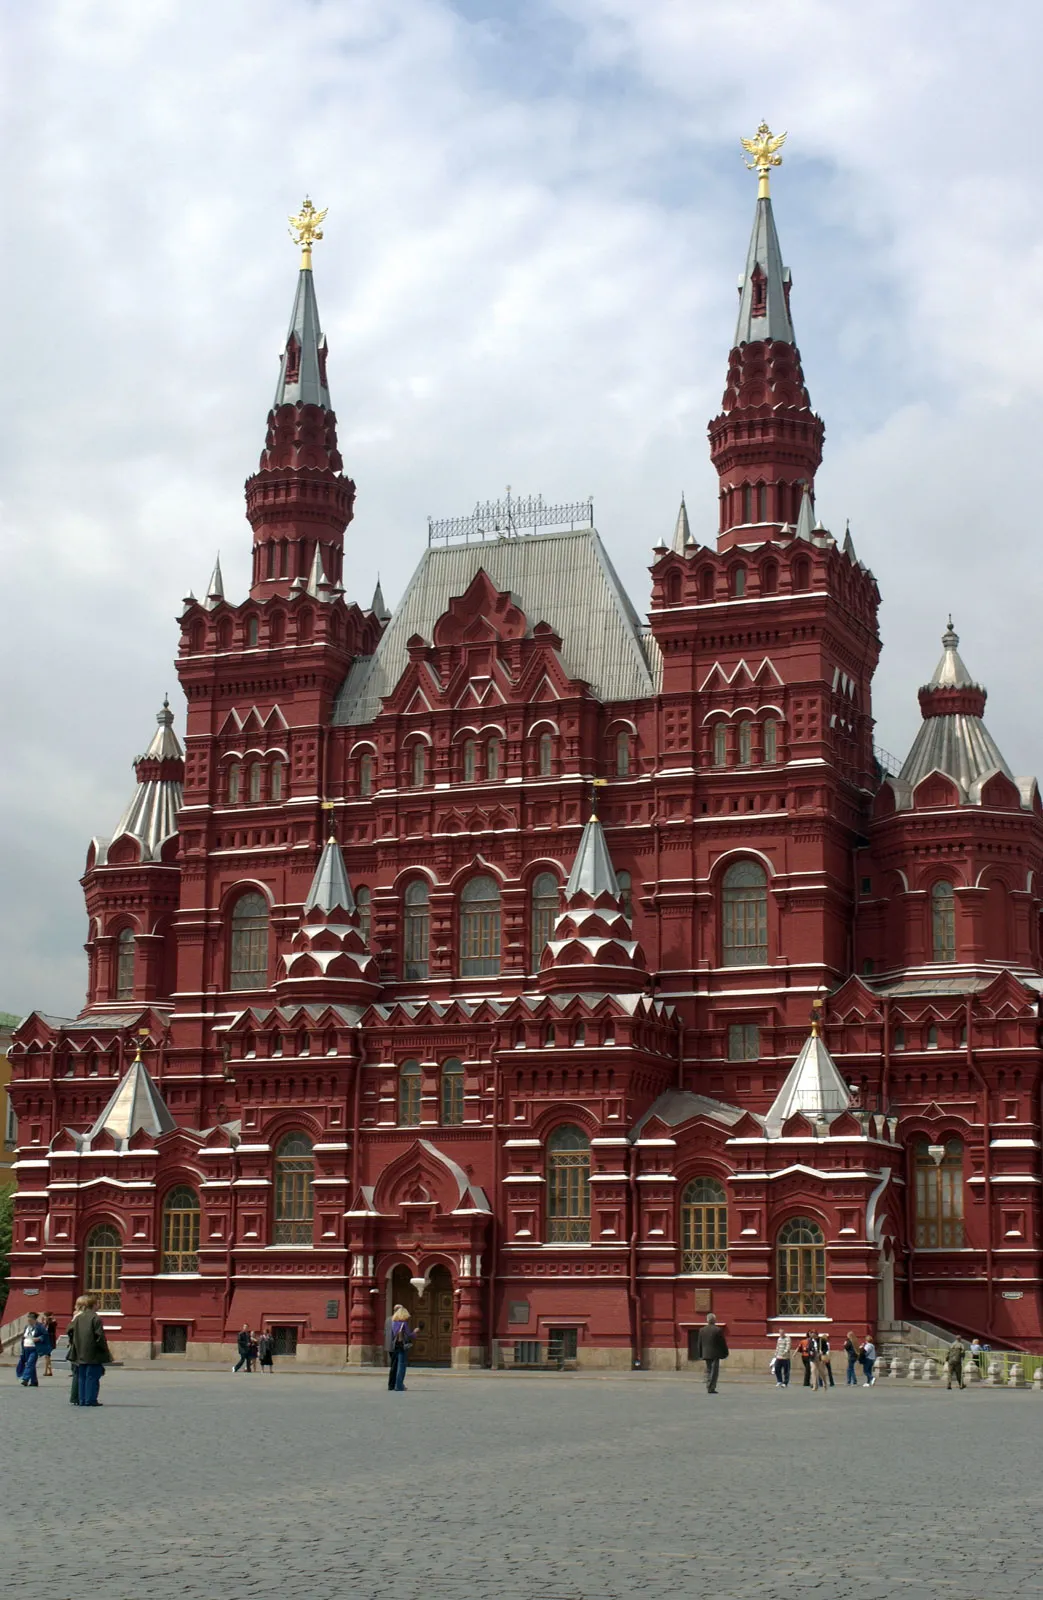Write a detailed description of the given image. The image reveals the State Historical Museum located in Moscow, Russia, rather than the Kremlin as previously identified. This striking structure is built in a Russian revival style, characterized by its vibrant red brick construction and ornate white detailing. Each embellished white-trimmed spire is capped with a distinctive black and gold pinnacle. The building stands impressively under a partly cloudy sky, and its scale is accentuated by the few people visible in the foreground, who appear quite small in comparison. This museum serves not only as a key tourist attraction but also as a treasure trove of Russian history, housing numerous relics and artifacts. 